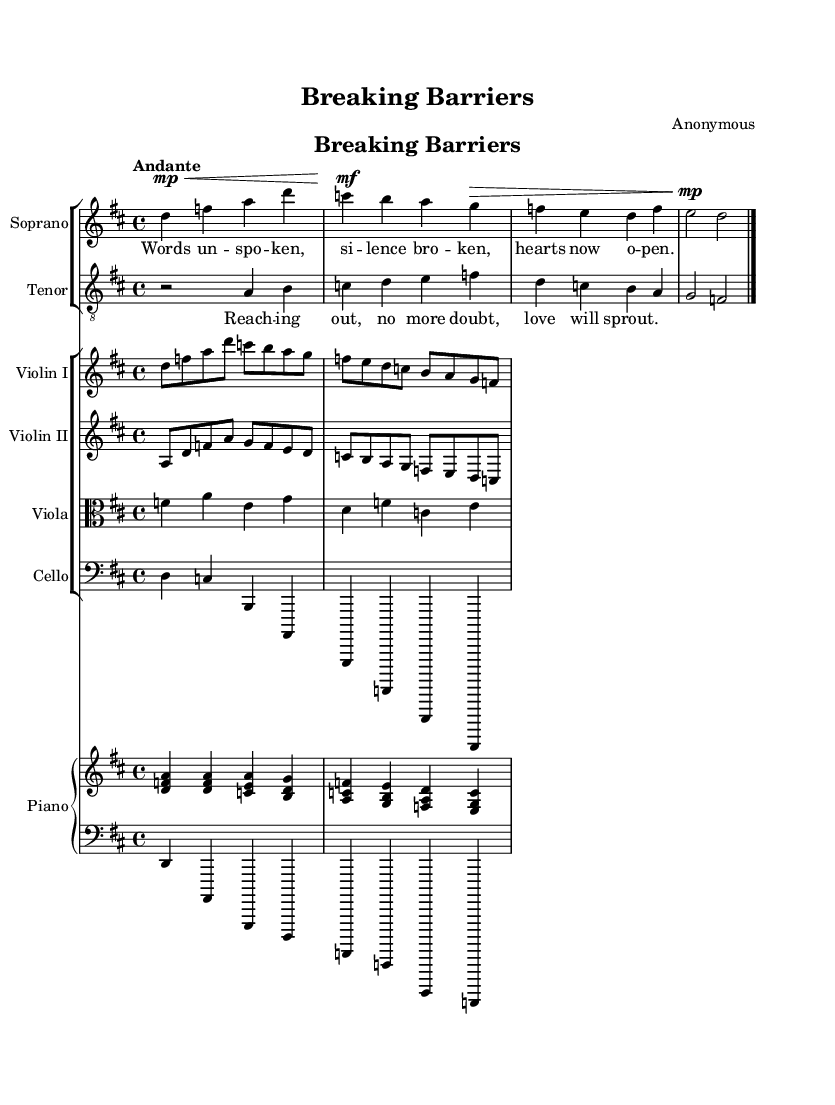What is the key signature of this music? The key signature is D major, which has two sharps (F# and C#). This can be identified by looking at the beginning of the staff where the sharps are indicated.
Answer: D major What is the time signature of this music? The time signature is 4/4, indicated at the beginning of the score. It shows that each measure contains four beats and the quarter note receives one beat.
Answer: 4/4 What is the tempo marking given for this piece? The tempo marking is "Andante," which indicates a moderate pace. This can be found in the instructions above the staves in the score.
Answer: Andante How many measures are there in the soprano part? To find the number of measures, we can count the distinct bar lines in the soprano part. There are four measures before the final bar line.
Answer: Four What emotions are expressed through the tenor's lyrics? The tenor's lyrics express hope and love, as evident from phrases like "Reaching out, no more doubt, love will sprout." This reflects a theme of overcoming barriers in communication.
Answer: Hope How does the music structure support the theme of overcoming barriers? The structure includes a dialogue between the soprano and tenor, reflecting communication. The contrasting dynamics and rising melodies signify the struggle and triumph in expressing emotions and connecting with others.
Answer: Dialogue What instruments accompany the soprano and tenor parts? The soprano and tenor parts are accompanied by a string section (two violins, viola, and cello) as well as a piano. This orchestration creates a fuller sound to enhance the operatic elements.
Answer: Strings and piano 